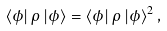Convert formula to latex. <formula><loc_0><loc_0><loc_500><loc_500>\left \langle \phi \right | \rho \left | \phi \right \rangle = \left \langle \phi \right | \rho \left | \phi \right \rangle ^ { 2 } ,</formula> 